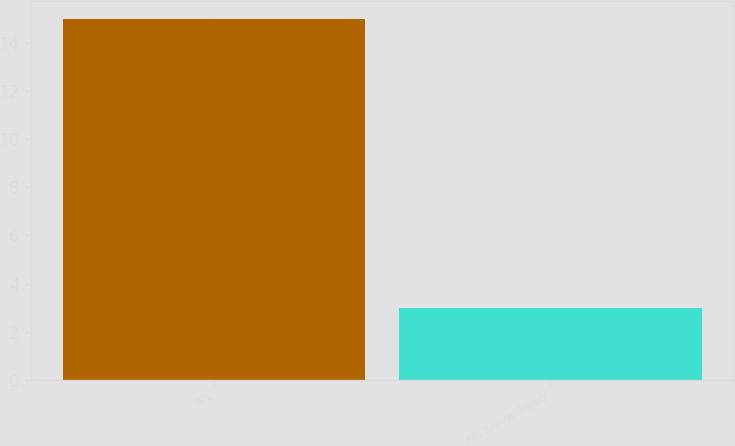<chart> <loc_0><loc_0><loc_500><loc_500><bar_chart><fcel>PPL<fcel>PPL Energy Supply<nl><fcel>15<fcel>3<nl></chart> 